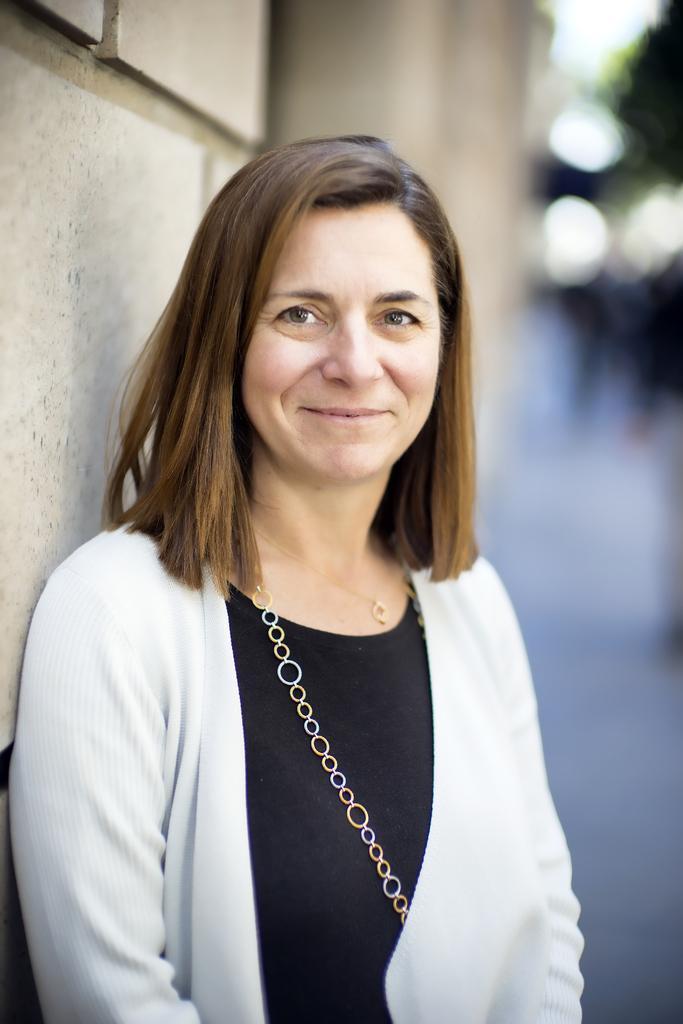Could you give a brief overview of what you see in this image? In the foreground I can see a woman is standing on a road. In the background I can see a wall, group of people, trees and the sky. This image is taken during a day on the road. 